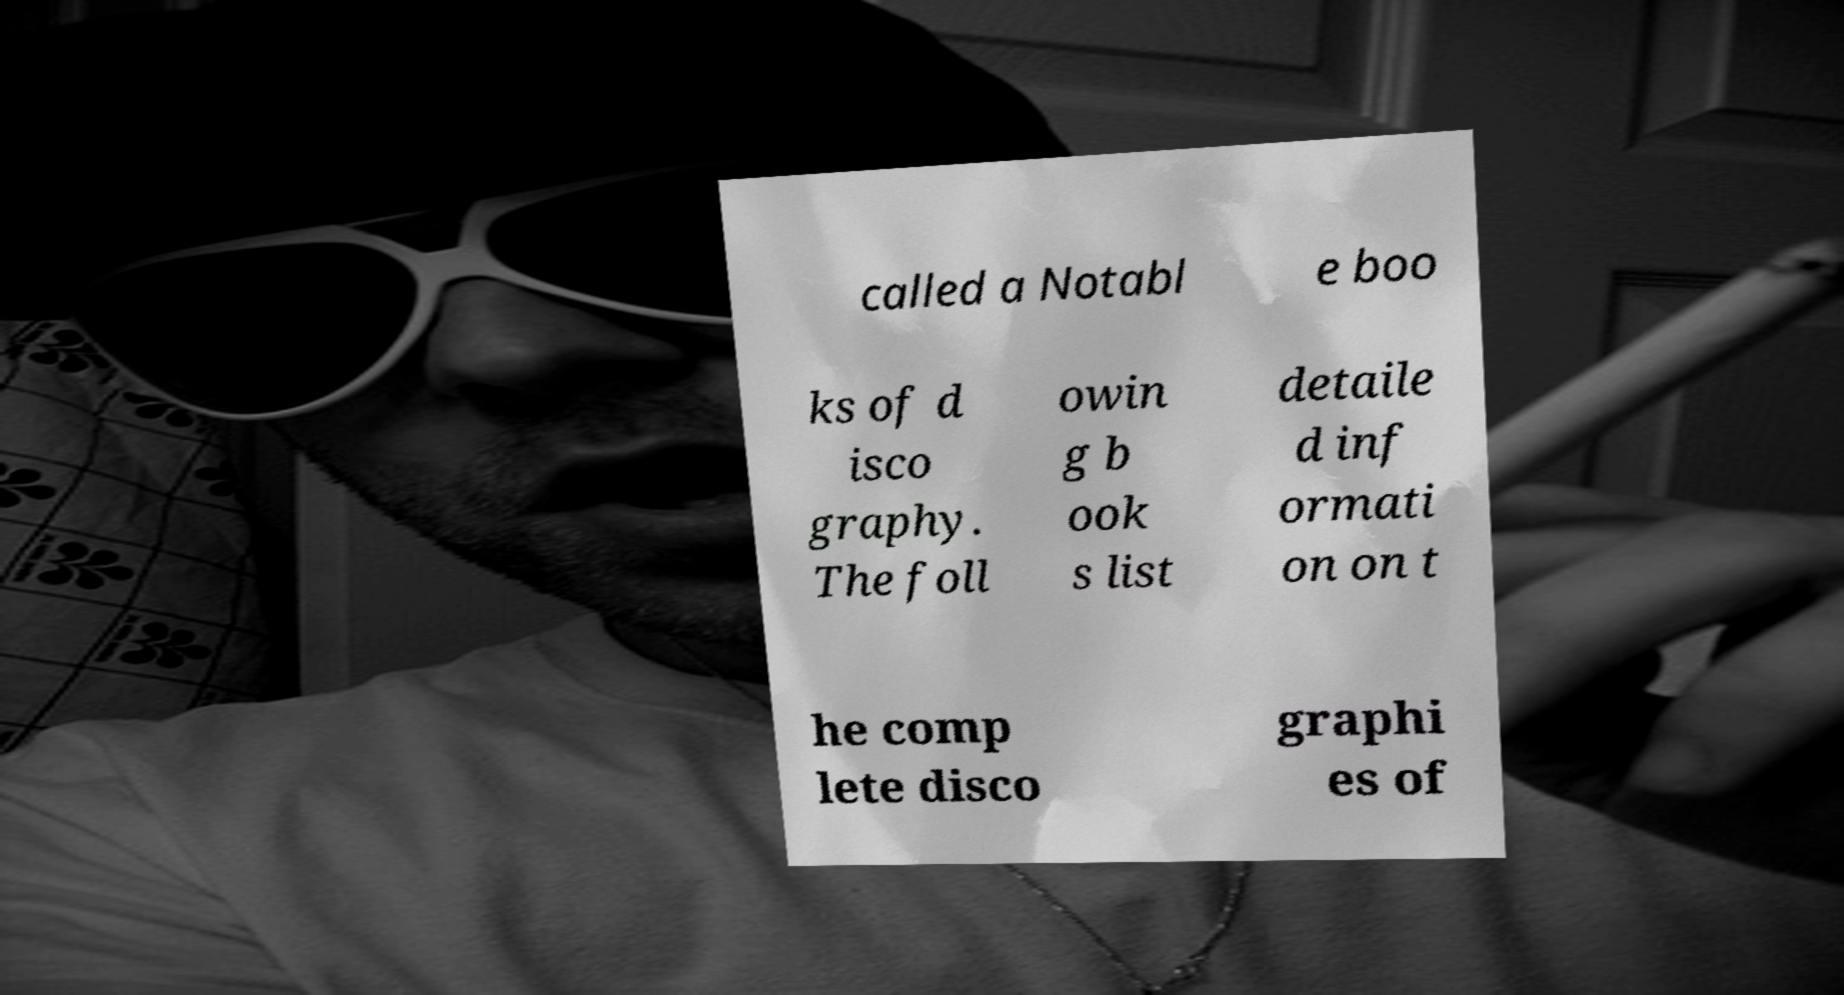Can you read and provide the text displayed in the image?This photo seems to have some interesting text. Can you extract and type it out for me? called a Notabl e boo ks of d isco graphy. The foll owin g b ook s list detaile d inf ormati on on t he comp lete disco graphi es of 